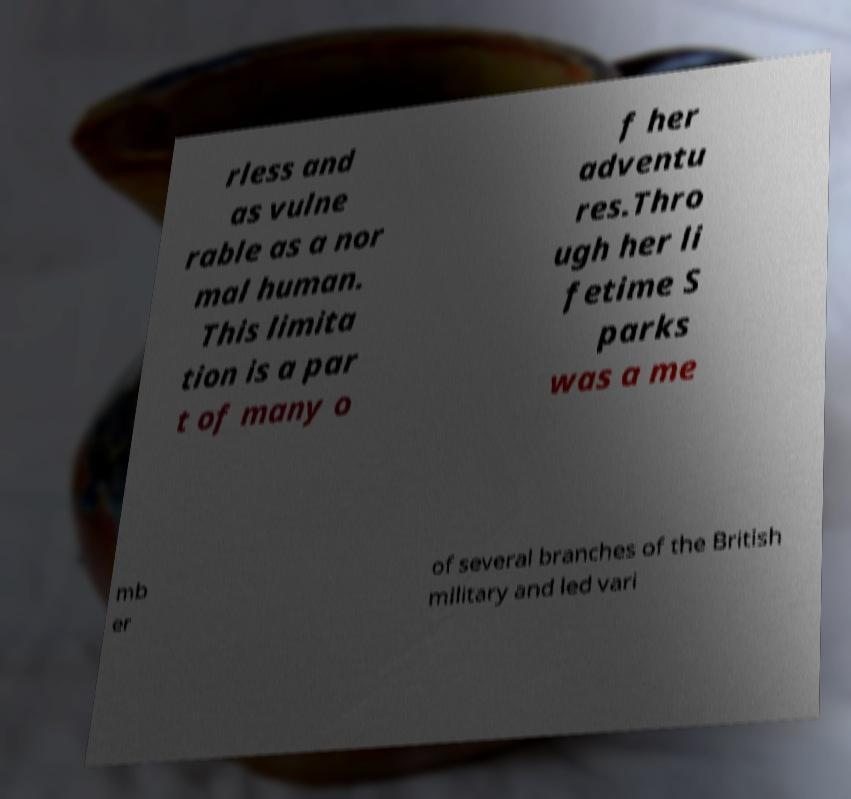Can you read and provide the text displayed in the image?This photo seems to have some interesting text. Can you extract and type it out for me? rless and as vulne rable as a nor mal human. This limita tion is a par t of many o f her adventu res.Thro ugh her li fetime S parks was a me mb er of several branches of the British military and led vari 